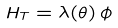Convert formula to latex. <formula><loc_0><loc_0><loc_500><loc_500>H _ { T } = \lambda ( \theta ) \, \phi</formula> 